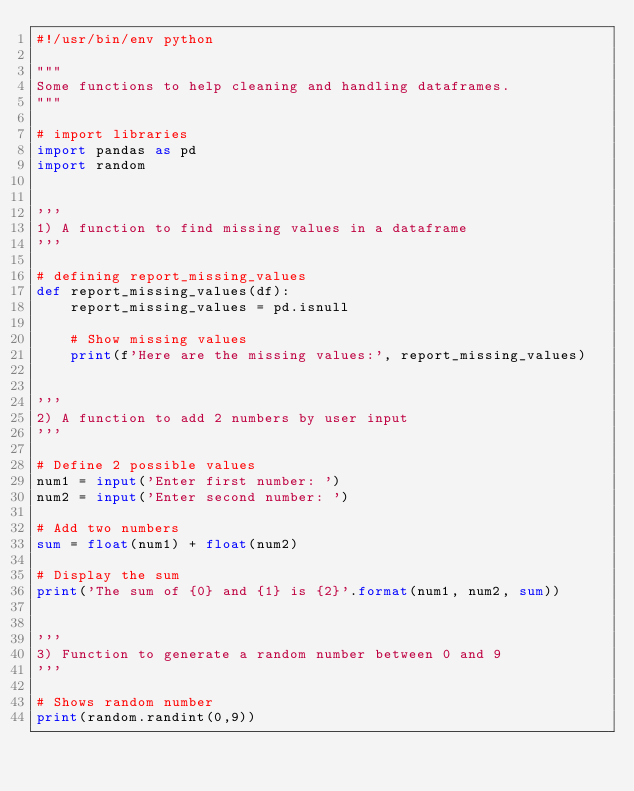Convert code to text. <code><loc_0><loc_0><loc_500><loc_500><_Python_>#!/usr/bin/env python

"""
Some functions to help cleaning and handling dataframes.
"""

# import libraries
import pandas as pd
import random


''' 
1) A function to find missing values in a dataframe 
'''

# defining report_missing_values
def report_missing_values(df):
    report_missing_values = pd.isnull  
    
    # Show missing values
    print(f'Here are the missing values:', report_missing_values)


''' 
2) A function to add 2 numbers by user input 
'''

# Define 2 possible values
num1 = input('Enter first number: ')
num2 = input('Enter second number: ')

# Add two numbers
sum = float(num1) + float(num2)

# Display the sum
print('The sum of {0} and {1} is {2}'.format(num1, num2, sum))


''' 
3) Function to generate a random number between 0 and 9 
'''

# Shows random number
print(random.randint(0,9))</code> 